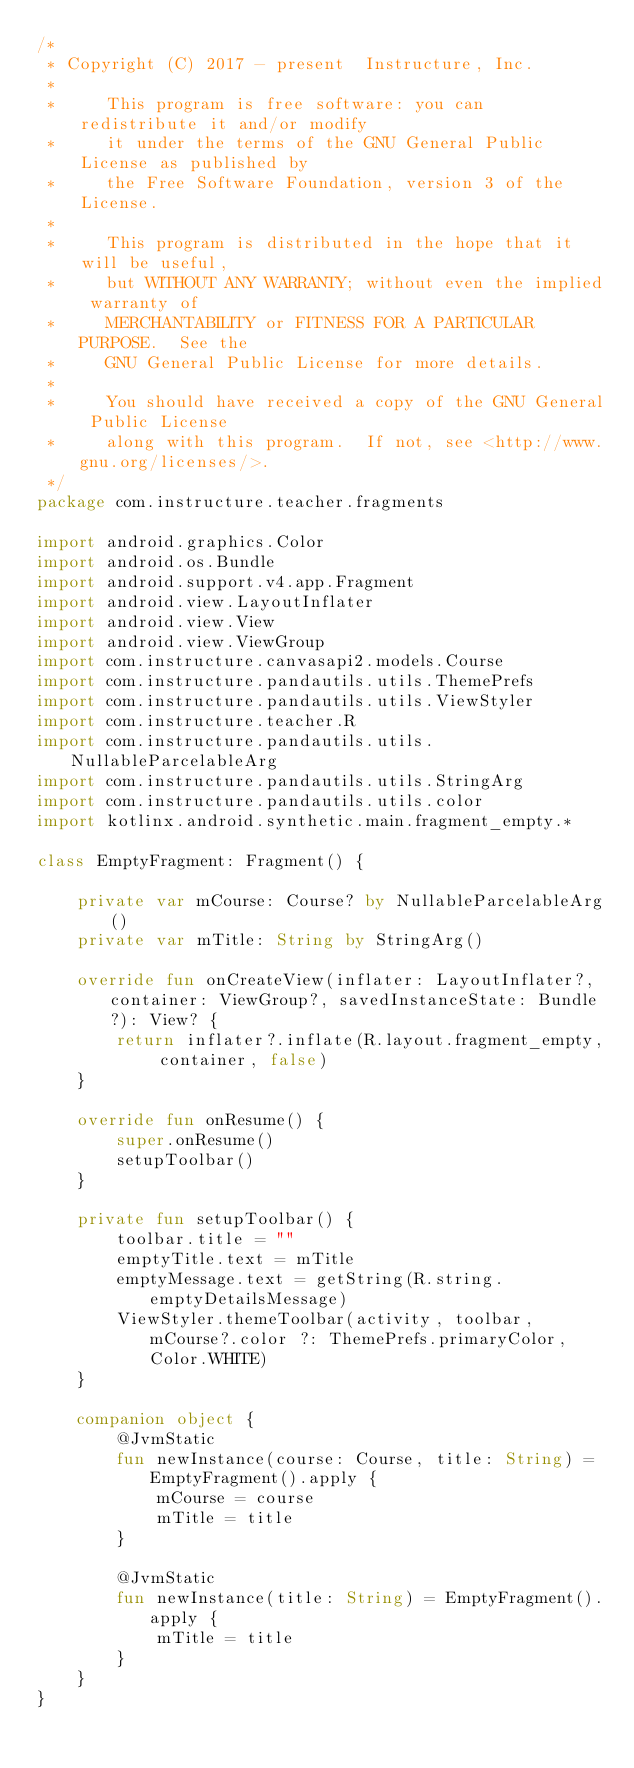<code> <loc_0><loc_0><loc_500><loc_500><_Kotlin_>/*
 * Copyright (C) 2017 - present  Instructure, Inc.
 *
 *     This program is free software: you can redistribute it and/or modify
 *     it under the terms of the GNU General Public License as published by
 *     the Free Software Foundation, version 3 of the License.
 *
 *     This program is distributed in the hope that it will be useful,
 *     but WITHOUT ANY WARRANTY; without even the implied warranty of
 *     MERCHANTABILITY or FITNESS FOR A PARTICULAR PURPOSE.  See the
 *     GNU General Public License for more details.
 *
 *     You should have received a copy of the GNU General Public License
 *     along with this program.  If not, see <http://www.gnu.org/licenses/>.
 */
package com.instructure.teacher.fragments

import android.graphics.Color
import android.os.Bundle
import android.support.v4.app.Fragment
import android.view.LayoutInflater
import android.view.View
import android.view.ViewGroup
import com.instructure.canvasapi2.models.Course
import com.instructure.pandautils.utils.ThemePrefs
import com.instructure.pandautils.utils.ViewStyler
import com.instructure.teacher.R
import com.instructure.pandautils.utils.NullableParcelableArg
import com.instructure.pandautils.utils.StringArg
import com.instructure.pandautils.utils.color
import kotlinx.android.synthetic.main.fragment_empty.*

class EmptyFragment: Fragment() {

    private var mCourse: Course? by NullableParcelableArg()
    private var mTitle: String by StringArg()

    override fun onCreateView(inflater: LayoutInflater?, container: ViewGroup?, savedInstanceState: Bundle?): View? {
        return inflater?.inflate(R.layout.fragment_empty, container, false)
    }

    override fun onResume() {
        super.onResume()
        setupToolbar()
    }

    private fun setupToolbar() {
        toolbar.title = ""
        emptyTitle.text = mTitle
        emptyMessage.text = getString(R.string.emptyDetailsMessage)
        ViewStyler.themeToolbar(activity, toolbar, mCourse?.color ?: ThemePrefs.primaryColor, Color.WHITE)
    }

    companion object {
        @JvmStatic
        fun newInstance(course: Course, title: String) = EmptyFragment().apply {
            mCourse = course
            mTitle = title
        }

        @JvmStatic
        fun newInstance(title: String) = EmptyFragment().apply {
            mTitle = title
        }
    }
}
</code> 